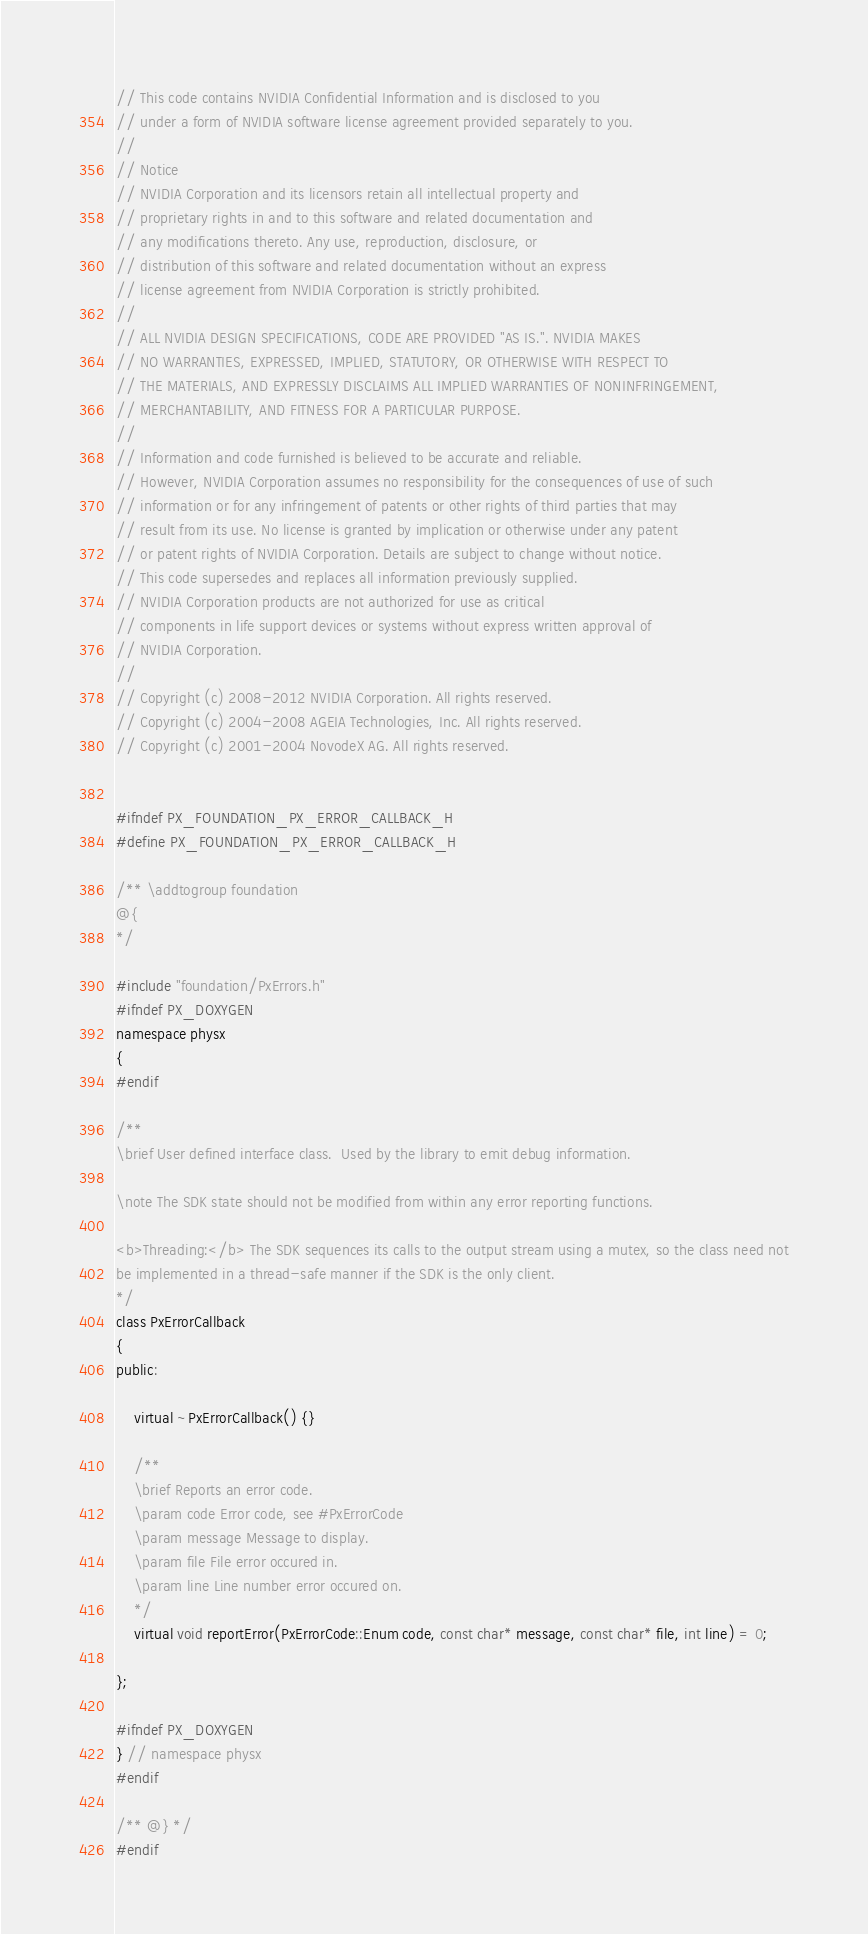<code> <loc_0><loc_0><loc_500><loc_500><_C_>// This code contains NVIDIA Confidential Information and is disclosed to you 
// under a form of NVIDIA software license agreement provided separately to you.
//
// Notice
// NVIDIA Corporation and its licensors retain all intellectual property and
// proprietary rights in and to this software and related documentation and 
// any modifications thereto. Any use, reproduction, disclosure, or 
// distribution of this software and related documentation without an express 
// license agreement from NVIDIA Corporation is strictly prohibited.
// 
// ALL NVIDIA DESIGN SPECIFICATIONS, CODE ARE PROVIDED "AS IS.". NVIDIA MAKES
// NO WARRANTIES, EXPRESSED, IMPLIED, STATUTORY, OR OTHERWISE WITH RESPECT TO
// THE MATERIALS, AND EXPRESSLY DISCLAIMS ALL IMPLIED WARRANTIES OF NONINFRINGEMENT,
// MERCHANTABILITY, AND FITNESS FOR A PARTICULAR PURPOSE.
//
// Information and code furnished is believed to be accurate and reliable.
// However, NVIDIA Corporation assumes no responsibility for the consequences of use of such
// information or for any infringement of patents or other rights of third parties that may
// result from its use. No license is granted by implication or otherwise under any patent
// or patent rights of NVIDIA Corporation. Details are subject to change without notice.
// This code supersedes and replaces all information previously supplied.
// NVIDIA Corporation products are not authorized for use as critical
// components in life support devices or systems without express written approval of
// NVIDIA Corporation.
//
// Copyright (c) 2008-2012 NVIDIA Corporation. All rights reserved.
// Copyright (c) 2004-2008 AGEIA Technologies, Inc. All rights reserved.
// Copyright (c) 2001-2004 NovodeX AG. All rights reserved.  


#ifndef PX_FOUNDATION_PX_ERROR_CALLBACK_H
#define PX_FOUNDATION_PX_ERROR_CALLBACK_H

/** \addtogroup foundation
@{
*/

#include "foundation/PxErrors.h"
#ifndef PX_DOXYGEN
namespace physx
{
#endif

/**
\brief User defined interface class.  Used by the library to emit debug information.

\note The SDK state should not be modified from within any error reporting functions.

<b>Threading:</b> The SDK sequences its calls to the output stream using a mutex, so the class need not
be implemented in a thread-safe manner if the SDK is the only client.
*/
class PxErrorCallback
{
public:

	virtual ~PxErrorCallback() {}

	/**
	\brief Reports an error code.
	\param code Error code, see #PxErrorCode
	\param message Message to display.
	\param file File error occured in.
	\param line Line number error occured on.
	*/
	virtual void reportError(PxErrorCode::Enum code, const char* message, const char* file, int line) = 0;

};

#ifndef PX_DOXYGEN
} // namespace physx
#endif

/** @} */
#endif
</code> 